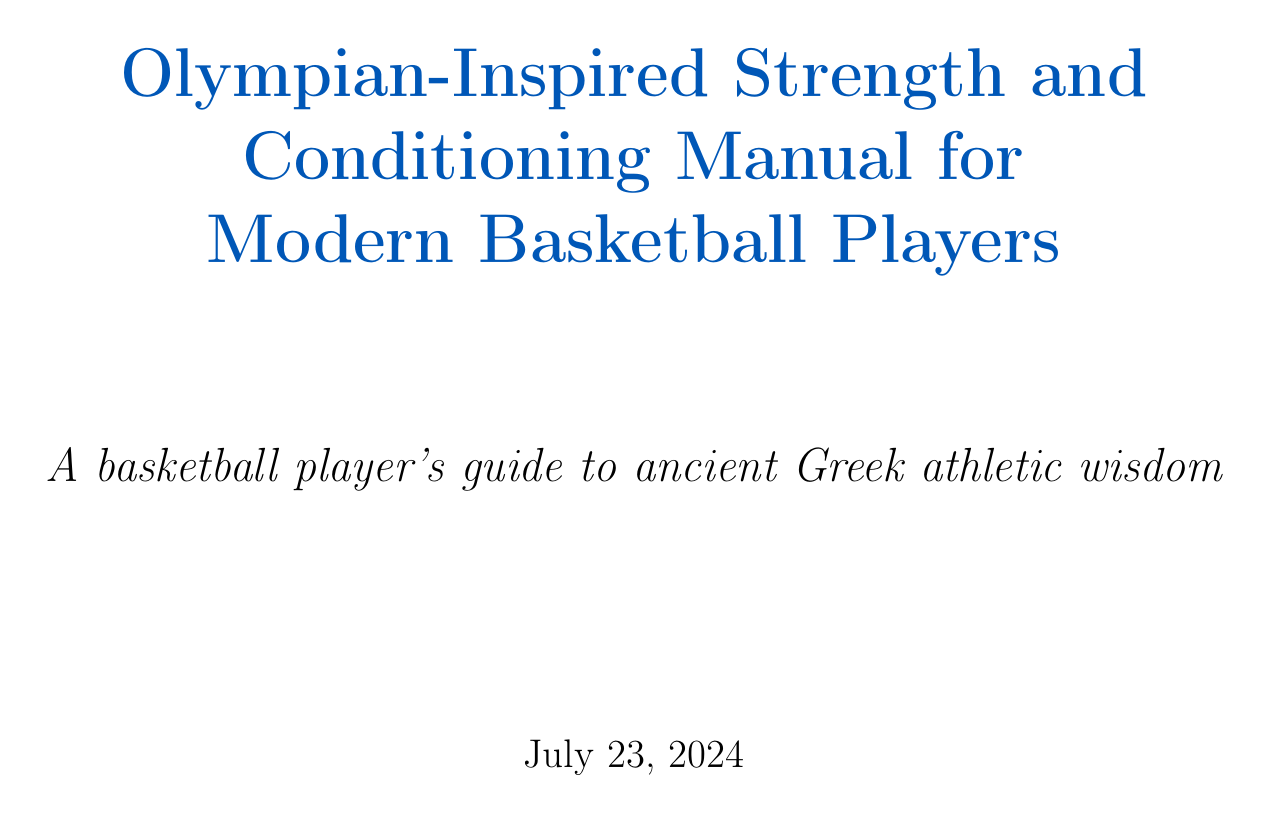What is the title of the manual? The title of the manual is provided at the beginning of the document.
Answer: Olympian-Inspired Strength and Conditioning Manual for Modern Basketball Players What is the primary mythological inspiration mentioned? The manual draws inspiration from Heracles as a metaphor for athletic training.
Answer: Heracles' Twelve Labors Name one exercise for rotational power. The document lists exercises for each section, and one is specifically mentioned for rotational power.
Answer: Medicine ball rotational throws How long is the duration of The Spartan Circuit workout? The duration for this specific workout is clearly stated in the document text.
Answer: 20 minutes What ancient Greek practice does hydrotherapy in the manual reference? This section discusses a method inspired by historical practices.
Answer: Bathing rituals Which area of the body is focused on for massage techniques? The document identifies specific target areas for massage based on ancient Greek practices.
Answer: Quadriceps List one food suggested for nutritional recovery. The manual lists several foods recommended for recovery after workouts.
Answer: Barley porridge with honey What type of training is used in the Grappling-Inspired Resistance section? The text specifies the type of training focused on in this section.
Answer: Partner exercises What principle does the Pentathlon Principle chapter emphasize? The chapter's emphasis is described in the title and throughout its content.
Answer: Comprehensive athletic development 